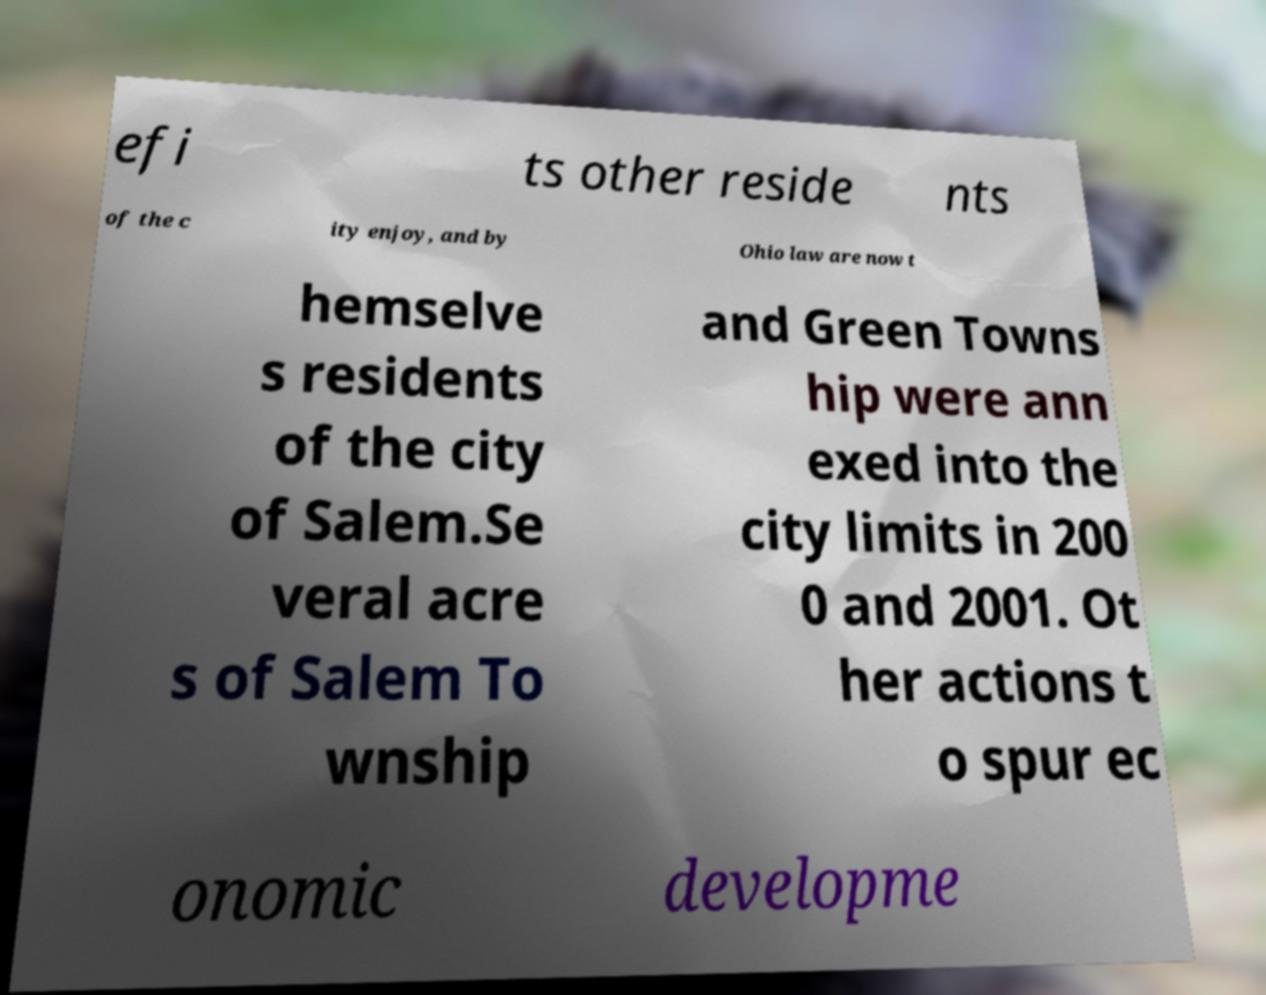There's text embedded in this image that I need extracted. Can you transcribe it verbatim? efi ts other reside nts of the c ity enjoy, and by Ohio law are now t hemselve s residents of the city of Salem.Se veral acre s of Salem To wnship and Green Towns hip were ann exed into the city limits in 200 0 and 2001. Ot her actions t o spur ec onomic developme 